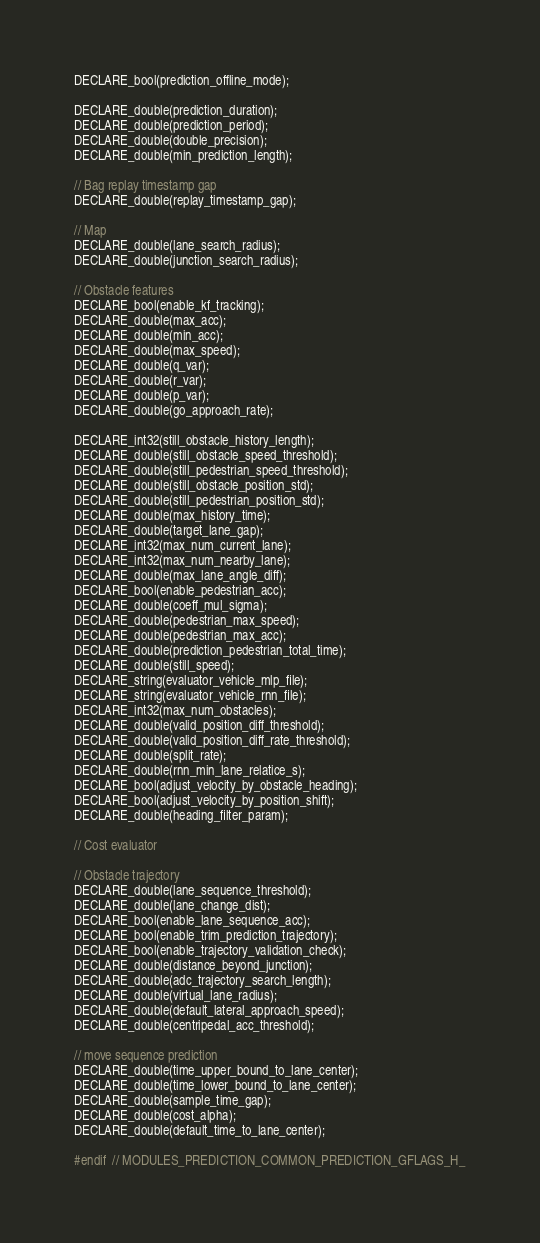<code> <loc_0><loc_0><loc_500><loc_500><_C_>DECLARE_bool(prediction_offline_mode);

DECLARE_double(prediction_duration);
DECLARE_double(prediction_period);
DECLARE_double(double_precision);
DECLARE_double(min_prediction_length);

// Bag replay timestamp gap
DECLARE_double(replay_timestamp_gap);

// Map
DECLARE_double(lane_search_radius);
DECLARE_double(junction_search_radius);

// Obstacle features
DECLARE_bool(enable_kf_tracking);
DECLARE_double(max_acc);
DECLARE_double(min_acc);
DECLARE_double(max_speed);
DECLARE_double(q_var);
DECLARE_double(r_var);
DECLARE_double(p_var);
DECLARE_double(go_approach_rate);

DECLARE_int32(still_obstacle_history_length);
DECLARE_double(still_obstacle_speed_threshold);
DECLARE_double(still_pedestrian_speed_threshold);
DECLARE_double(still_obstacle_position_std);
DECLARE_double(still_pedestrian_position_std);
DECLARE_double(max_history_time);
DECLARE_double(target_lane_gap);
DECLARE_int32(max_num_current_lane);
DECLARE_int32(max_num_nearby_lane);
DECLARE_double(max_lane_angle_diff);
DECLARE_bool(enable_pedestrian_acc);
DECLARE_double(coeff_mul_sigma);
DECLARE_double(pedestrian_max_speed);
DECLARE_double(pedestrian_max_acc);
DECLARE_double(prediction_pedestrian_total_time);
DECLARE_double(still_speed);
DECLARE_string(evaluator_vehicle_mlp_file);
DECLARE_string(evaluator_vehicle_rnn_file);
DECLARE_int32(max_num_obstacles);
DECLARE_double(valid_position_diff_threshold);
DECLARE_double(valid_position_diff_rate_threshold);
DECLARE_double(split_rate);
DECLARE_double(rnn_min_lane_relatice_s);
DECLARE_bool(adjust_velocity_by_obstacle_heading);
DECLARE_bool(adjust_velocity_by_position_shift);
DECLARE_double(heading_filter_param);

// Cost evaluator

// Obstacle trajectory
DECLARE_double(lane_sequence_threshold);
DECLARE_double(lane_change_dist);
DECLARE_bool(enable_lane_sequence_acc);
DECLARE_bool(enable_trim_prediction_trajectory);
DECLARE_bool(enable_trajectory_validation_check);
DECLARE_double(distance_beyond_junction);
DECLARE_double(adc_trajectory_search_length);
DECLARE_double(virtual_lane_radius);
DECLARE_double(default_lateral_approach_speed);
DECLARE_double(centripedal_acc_threshold);

// move sequence prediction
DECLARE_double(time_upper_bound_to_lane_center);
DECLARE_double(time_lower_bound_to_lane_center);
DECLARE_double(sample_time_gap);
DECLARE_double(cost_alpha);
DECLARE_double(default_time_to_lane_center);

#endif  // MODULES_PREDICTION_COMMON_PREDICTION_GFLAGS_H_
</code> 